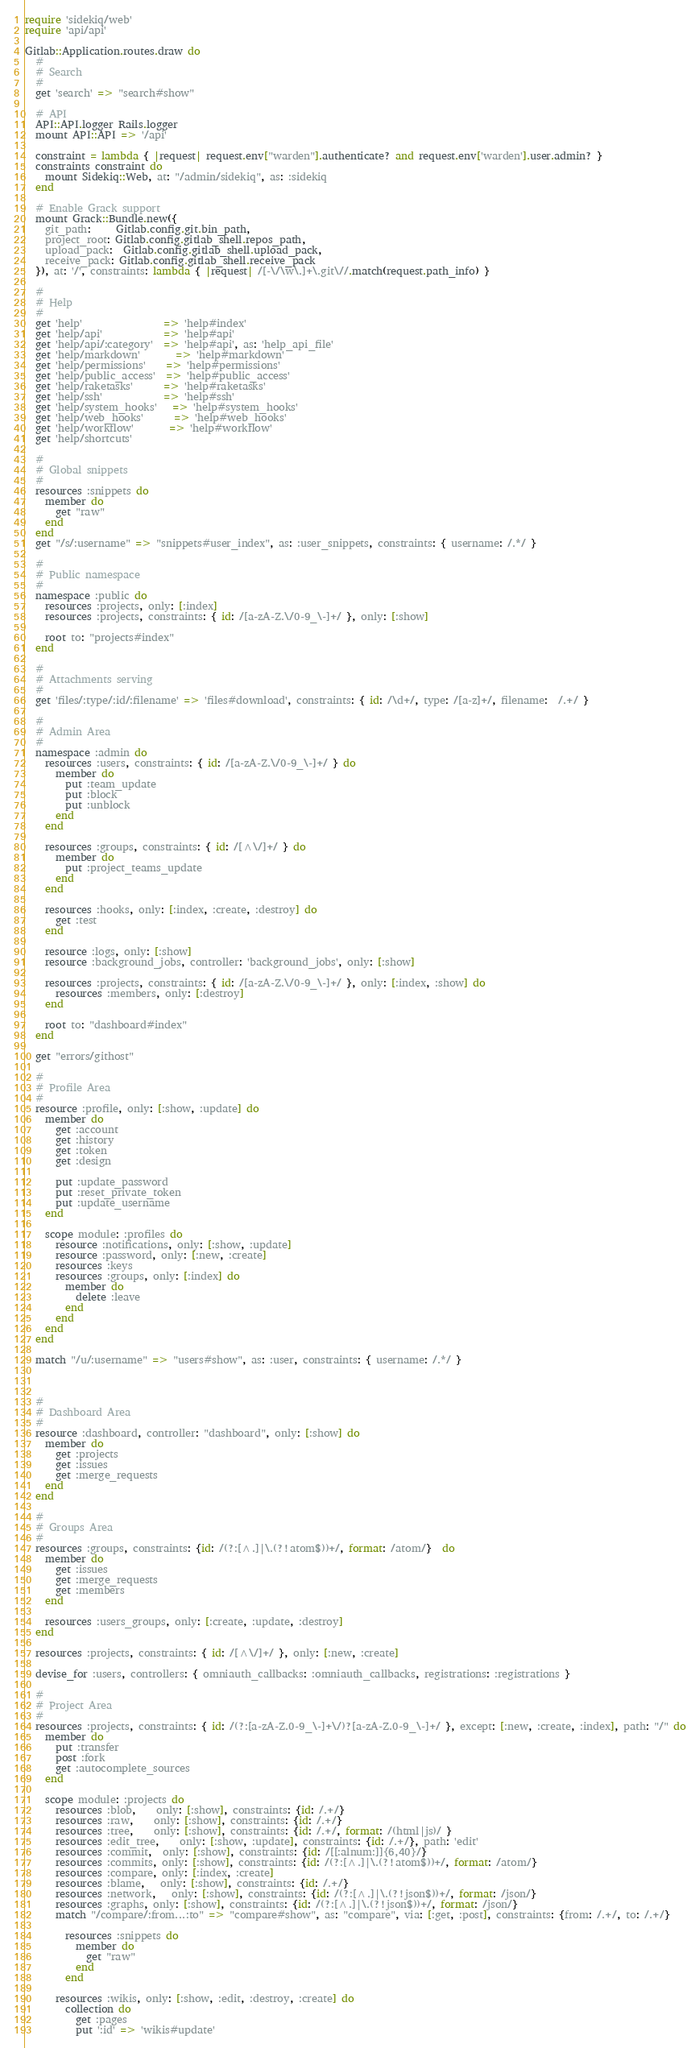Convert code to text. <code><loc_0><loc_0><loc_500><loc_500><_Ruby_>require 'sidekiq/web'
require 'api/api'

Gitlab::Application.routes.draw do
  #
  # Search
  #
  get 'search' => "search#show"

  # API
  API::API.logger Rails.logger
  mount API::API => '/api'

  constraint = lambda { |request| request.env["warden"].authenticate? and request.env['warden'].user.admin? }
  constraints constraint do
    mount Sidekiq::Web, at: "/admin/sidekiq", as: :sidekiq
  end

  # Enable Grack support
  mount Grack::Bundle.new({
    git_path:     Gitlab.config.git.bin_path,
    project_root: Gitlab.config.gitlab_shell.repos_path,
    upload_pack:  Gitlab.config.gitlab_shell.upload_pack,
    receive_pack: Gitlab.config.gitlab_shell.receive_pack
  }), at: '/', constraints: lambda { |request| /[-\/\w\.]+\.git\//.match(request.path_info) }

  #
  # Help
  #
  get 'help'                => 'help#index'
  get 'help/api'            => 'help#api'
  get 'help/api/:category'  => 'help#api', as: 'help_api_file'
  get 'help/markdown'       => 'help#markdown'
  get 'help/permissions'    => 'help#permissions'
  get 'help/public_access'  => 'help#public_access'
  get 'help/raketasks'      => 'help#raketasks'
  get 'help/ssh'            => 'help#ssh'
  get 'help/system_hooks'   => 'help#system_hooks'
  get 'help/web_hooks'      => 'help#web_hooks'
  get 'help/workflow'       => 'help#workflow'
  get 'help/shortcuts'

  #
  # Global snippets
  #
  resources :snippets do
    member do
      get "raw"
    end
  end
  get "/s/:username" => "snippets#user_index", as: :user_snippets, constraints: { username: /.*/ }

  #
  # Public namespace
  #
  namespace :public do
    resources :projects, only: [:index]
    resources :projects, constraints: { id: /[a-zA-Z.\/0-9_\-]+/ }, only: [:show]

    root to: "projects#index"
  end

  #
  # Attachments serving
  #
  get 'files/:type/:id/:filename' => 'files#download', constraints: { id: /\d+/, type: /[a-z]+/, filename:  /.+/ }

  #
  # Admin Area
  #
  namespace :admin do
    resources :users, constraints: { id: /[a-zA-Z.\/0-9_\-]+/ } do
      member do
        put :team_update
        put :block
        put :unblock
      end
    end

    resources :groups, constraints: { id: /[^\/]+/ } do
      member do
        put :project_teams_update
      end
    end

    resources :hooks, only: [:index, :create, :destroy] do
      get :test
    end

    resource :logs, only: [:show]
    resource :background_jobs, controller: 'background_jobs', only: [:show]

    resources :projects, constraints: { id: /[a-zA-Z.\/0-9_\-]+/ }, only: [:index, :show] do
      resources :members, only: [:destroy]
    end

    root to: "dashboard#index"
  end

  get "errors/githost"

  #
  # Profile Area
  #
  resource :profile, only: [:show, :update] do
    member do
      get :account
      get :history
      get :token
      get :design

      put :update_password
      put :reset_private_token
      put :update_username
    end

    scope module: :profiles do
      resource :notifications, only: [:show, :update]
      resource :password, only: [:new, :create]
      resources :keys
      resources :groups, only: [:index] do
        member do
          delete :leave
        end
      end
    end
  end

  match "/u/:username" => "users#show", as: :user, constraints: { username: /.*/ }



  #
  # Dashboard Area
  #
  resource :dashboard, controller: "dashboard", only: [:show] do
    member do
      get :projects
      get :issues
      get :merge_requests
    end
  end

  #
  # Groups Area
  #
  resources :groups, constraints: {id: /(?:[^.]|\.(?!atom$))+/, format: /atom/}  do
    member do
      get :issues
      get :merge_requests
      get :members
    end

    resources :users_groups, only: [:create, :update, :destroy]
  end

  resources :projects, constraints: { id: /[^\/]+/ }, only: [:new, :create]

  devise_for :users, controllers: { omniauth_callbacks: :omniauth_callbacks, registrations: :registrations }

  #
  # Project Area
  #
  resources :projects, constraints: { id: /(?:[a-zA-Z.0-9_\-]+\/)?[a-zA-Z.0-9_\-]+/ }, except: [:new, :create, :index], path: "/" do
    member do
      put :transfer
      post :fork
      get :autocomplete_sources
    end

    scope module: :projects do
      resources :blob,    only: [:show], constraints: {id: /.+/}
      resources :raw,    only: [:show], constraints: {id: /.+/}
      resources :tree,    only: [:show], constraints: {id: /.+/, format: /(html|js)/ }
      resources :edit_tree,    only: [:show, :update], constraints: {id: /.+/}, path: 'edit'
      resources :commit,  only: [:show], constraints: {id: /[[:alnum:]]{6,40}/}
      resources :commits, only: [:show], constraints: {id: /(?:[^.]|\.(?!atom$))+/, format: /atom/}
      resources :compare, only: [:index, :create]
      resources :blame,   only: [:show], constraints: {id: /.+/}
      resources :network,   only: [:show], constraints: {id: /(?:[^.]|\.(?!json$))+/, format: /json/}
      resources :graphs, only: [:show], constraints: {id: /(?:[^.]|\.(?!json$))+/, format: /json/}
      match "/compare/:from...:to" => "compare#show", as: "compare", via: [:get, :post], constraints: {from: /.+/, to: /.+/}

        resources :snippets do
          member do
            get "raw"
          end
        end

      resources :wikis, only: [:show, :edit, :destroy, :create] do
        collection do
          get :pages
          put ':id' => 'wikis#update'</code> 